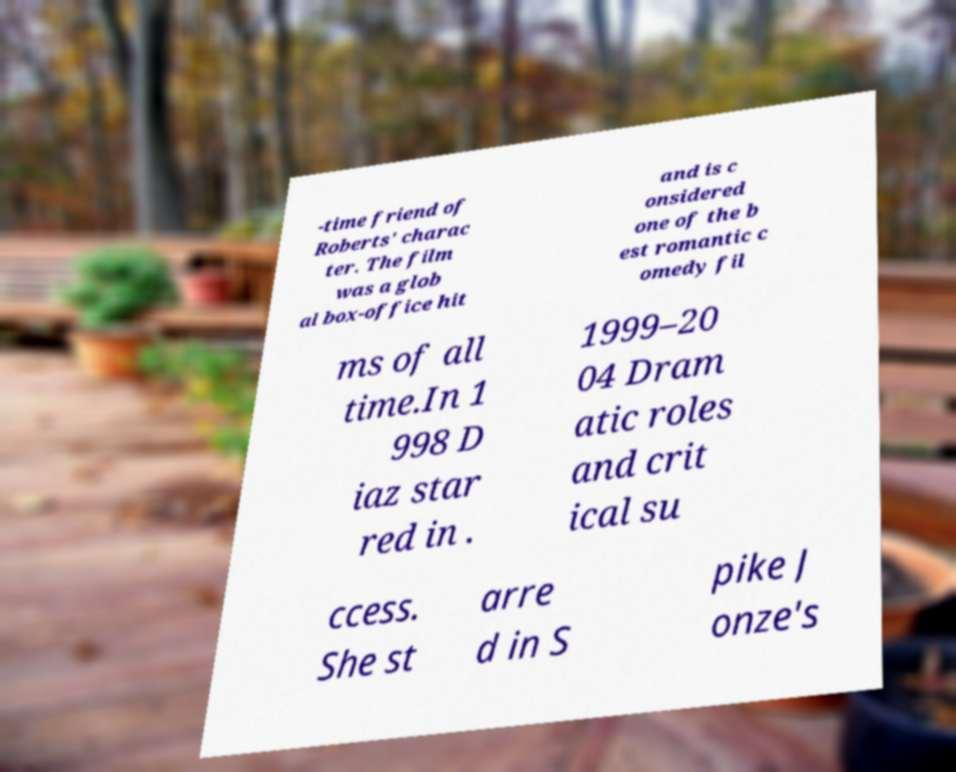Please read and relay the text visible in this image. What does it say? -time friend of Roberts' charac ter. The film was a glob al box-office hit and is c onsidered one of the b est romantic c omedy fil ms of all time.In 1 998 D iaz star red in . 1999–20 04 Dram atic roles and crit ical su ccess. She st arre d in S pike J onze's 